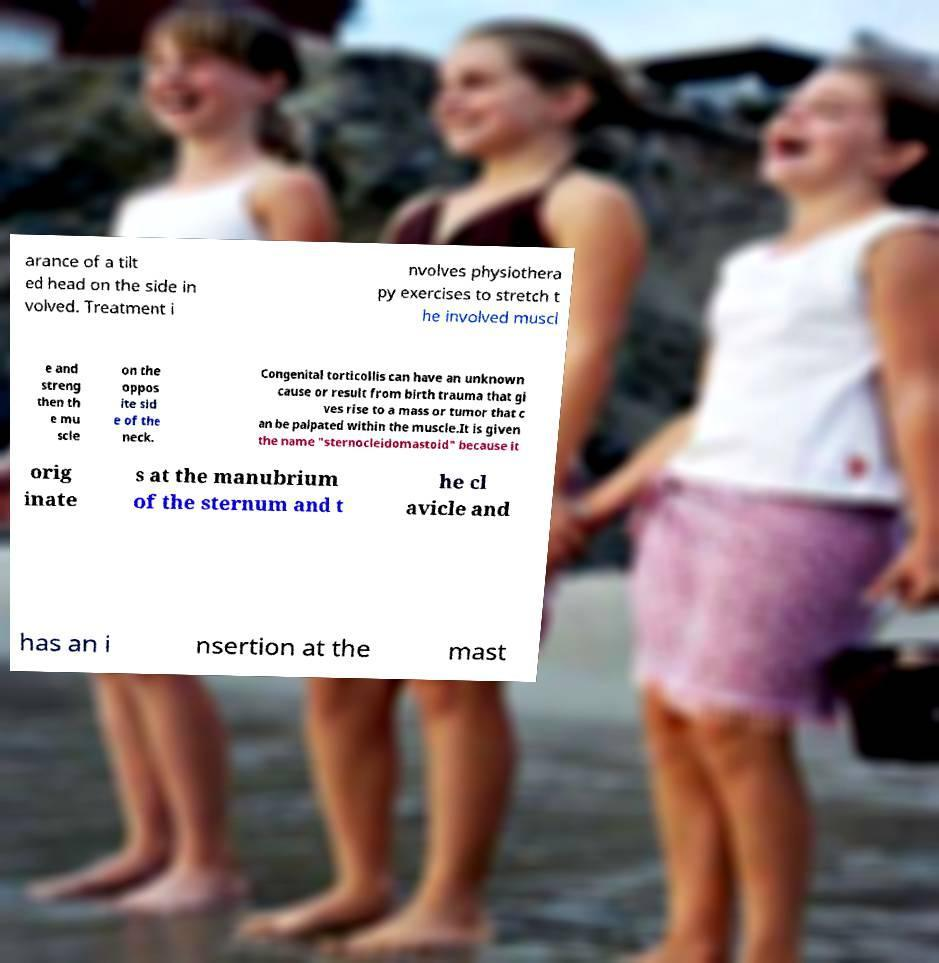Please identify and transcribe the text found in this image. arance of a tilt ed head on the side in volved. Treatment i nvolves physiothera py exercises to stretch t he involved muscl e and streng then th e mu scle on the oppos ite sid e of the neck. Congenital torticollis can have an unknown cause or result from birth trauma that gi ves rise to a mass or tumor that c an be palpated within the muscle.It is given the name "sternocleidomastoid" because it orig inate s at the manubrium of the sternum and t he cl avicle and has an i nsertion at the mast 